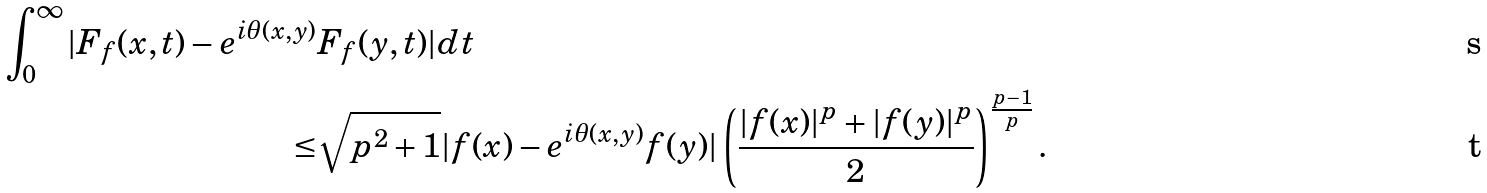Convert formula to latex. <formula><loc_0><loc_0><loc_500><loc_500>\int _ { 0 } ^ { \infty } | F _ { f } ( x , t ) - e ^ { i \theta ( x , y ) } & F _ { f } ( y , t ) | d t \\ \leq & { \sqrt { p ^ { 2 } + 1 } } | f ( x ) - e ^ { i \theta ( x , y ) } f ( y ) | \left ( \frac { | f ( x ) | ^ { p } + | f ( y ) | ^ { p } } 2 \right ) ^ { \frac { p - 1 } p } .</formula> 